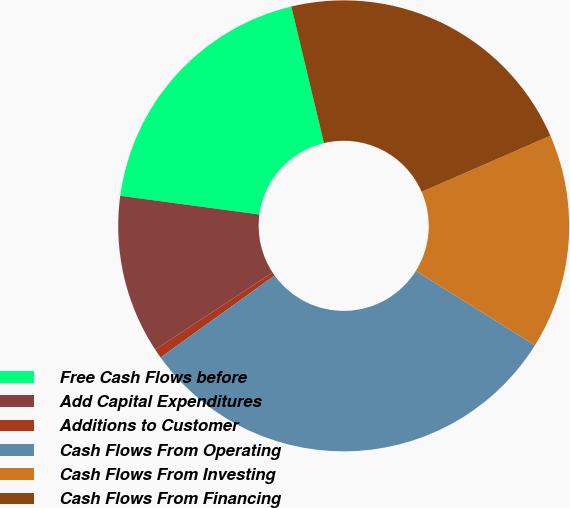Convert chart to OTSL. <chart><loc_0><loc_0><loc_500><loc_500><pie_chart><fcel>Free Cash Flows before<fcel>Add Capital Expenditures<fcel>Additions to Customer<fcel>Cash Flows From Operating<fcel>Cash Flows From Investing<fcel>Cash Flows From Financing<nl><fcel>19.14%<fcel>11.37%<fcel>0.68%<fcel>31.19%<fcel>15.43%<fcel>22.19%<nl></chart> 